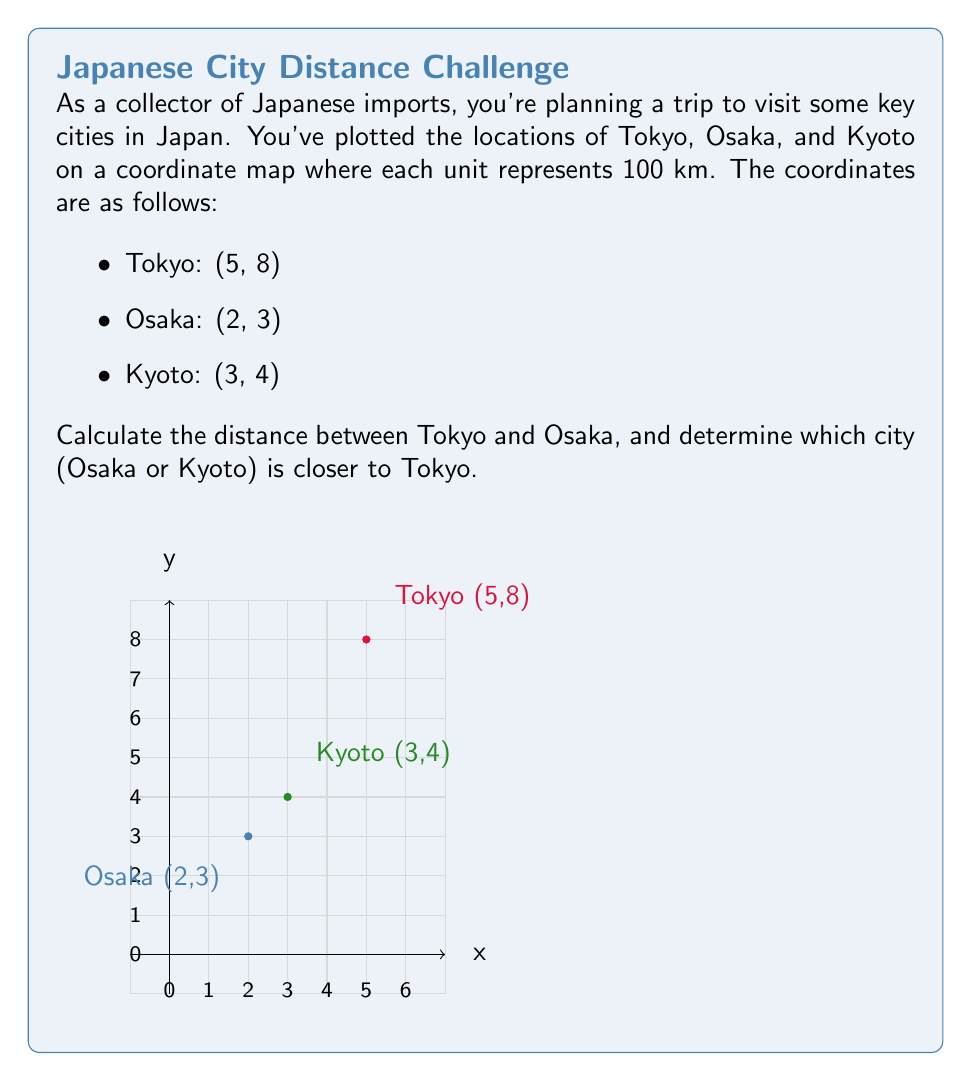Can you solve this math problem? Let's approach this problem step-by-step:

1) To calculate the distance between two points, we use the distance formula:
   $$d = \sqrt{(x_2-x_1)^2 + (y_2-y_1)^2}$$

2) For Tokyo (5,8) and Osaka (2,3):
   $$d_{Tokyo-Osaka} = \sqrt{(2-5)^2 + (3-8)^2}$$
   $$= \sqrt{(-3)^2 + (-5)^2}$$
   $$= \sqrt{9 + 25}$$
   $$= \sqrt{34}$$
   $$\approx 5.83$$

3) Since each unit represents 100 km, the actual distance is:
   $$5.83 \times 100 = 583 \text{ km}$$

4) Now, let's calculate the distance between Tokyo and Kyoto:
   $$d_{Tokyo-Kyoto} = \sqrt{(3-5)^2 + (4-8)^2}$$
   $$= \sqrt{(-2)^2 + (-4)^2}$$
   $$= \sqrt{4 + 16}$$
   $$= \sqrt{20}$$
   $$\approx 4.47$$

5) The actual distance between Tokyo and Kyoto is:
   $$4.47 \times 100 = 447 \text{ km}$$

6) Comparing the distances:
   Tokyo to Osaka: 583 km
   Tokyo to Kyoto: 447 km

Therefore, Kyoto is closer to Tokyo than Osaka.
Answer: 583 km; Kyoto is closer 